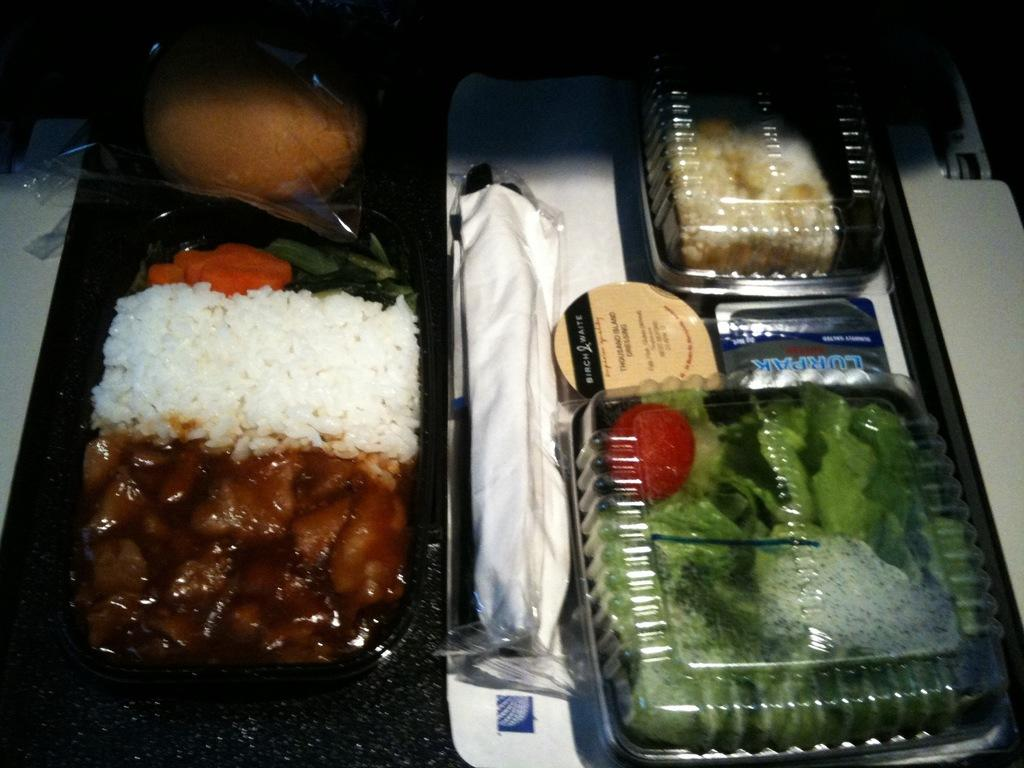<image>
Create a compact narrative representing the image presented. A container of thousand island dressing sits on the tray next to a salad. 